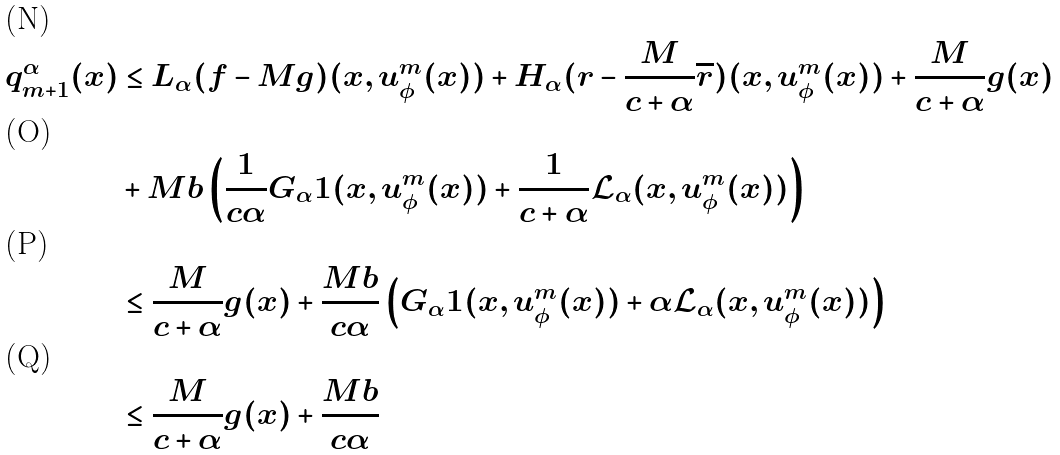<formula> <loc_0><loc_0><loc_500><loc_500>q ^ { \alpha } _ { m + 1 } ( x ) & \leq L _ { \alpha } ( f - M g ) ( x , u ^ { m } _ { \phi } ( x ) ) + H _ { \alpha } ( r - \frac { M } { c + \alpha } \overline { r } ) ( x , u ^ { m } _ { \phi } ( x ) ) + \frac { M } { c + \alpha } g ( x ) \\ & + M b \left ( \frac { 1 } { c \alpha } G _ { \alpha } 1 ( x , u ^ { m } _ { \phi } ( x ) ) + \frac { 1 } { c + \alpha } \mathcal { L } _ { \alpha } ( x , u ^ { m } _ { \phi } ( x ) ) \right ) \\ & \leq \frac { M } { c + \alpha } g ( x ) + \frac { M b } { c \alpha } \left ( G _ { \alpha } 1 ( x , u ^ { m } _ { \phi } ( x ) ) + \alpha \mathcal { L } _ { \alpha } ( x , u ^ { m } _ { \phi } ( x ) ) \right ) \\ & \leq \frac { M } { c + \alpha } g ( x ) + \frac { M b } { c \alpha }</formula> 